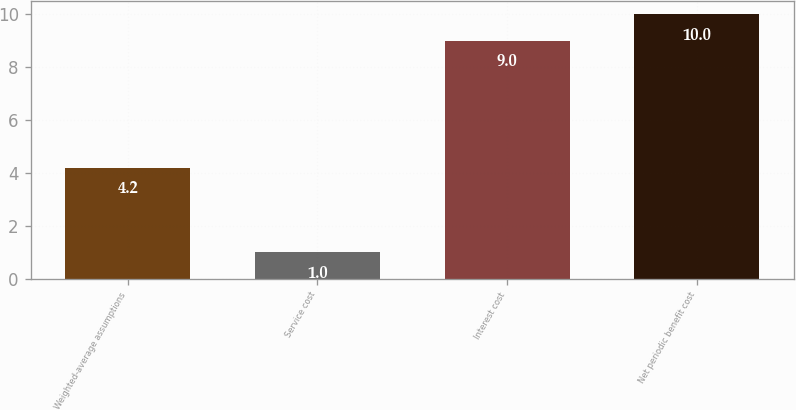Convert chart to OTSL. <chart><loc_0><loc_0><loc_500><loc_500><bar_chart><fcel>Weighted-average assumptions<fcel>Service cost<fcel>Interest cost<fcel>Net periodic benefit cost<nl><fcel>4.2<fcel>1<fcel>9<fcel>10<nl></chart> 